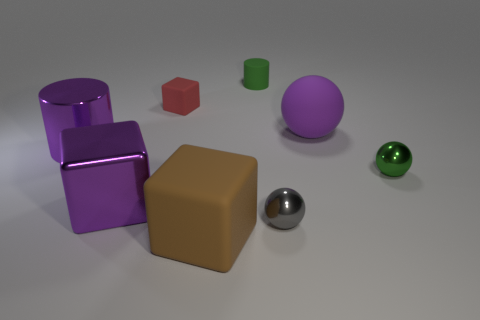What might this assortment of objects represent? This assortment of objects could represent a study in geometry and material properties, showcasing different shapes like cylinders, cubes, and spheres along with a variety of surface qualities, from matte to shiny finishes. 